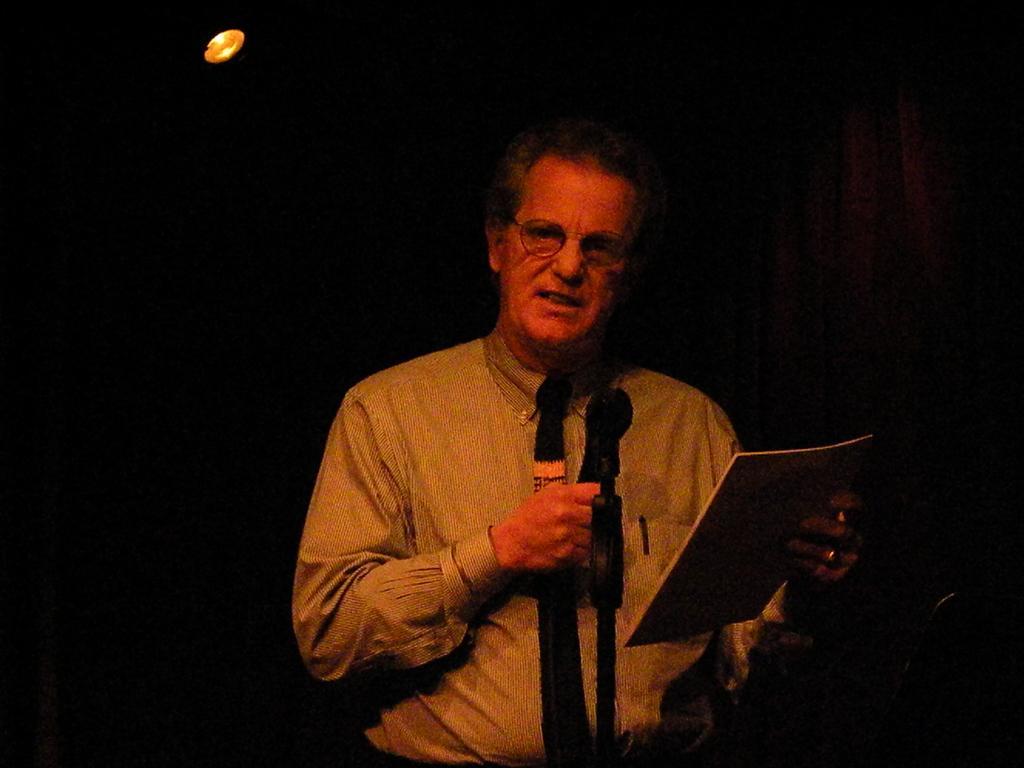Could you give a brief overview of what you see in this image? In this image we can see a man holding a mic in his right hand and speaking. He is also holding a book in his left hand. This is the light. 